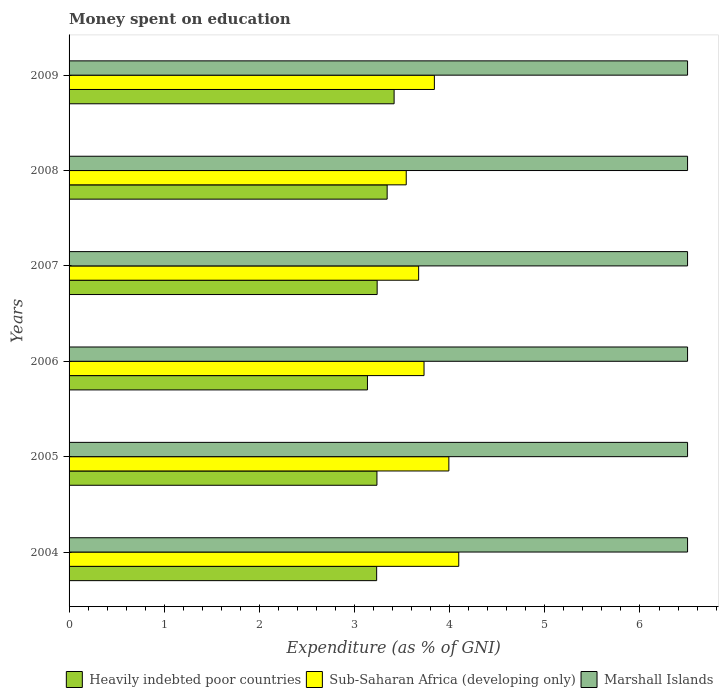How many different coloured bars are there?
Make the answer very short. 3. How many groups of bars are there?
Make the answer very short. 6. How many bars are there on the 3rd tick from the top?
Provide a short and direct response. 3. In how many cases, is the number of bars for a given year not equal to the number of legend labels?
Offer a terse response. 0. What is the amount of money spent on education in Marshall Islands in 2008?
Offer a very short reply. 6.5. Across all years, what is the minimum amount of money spent on education in Marshall Islands?
Your answer should be compact. 6.5. In which year was the amount of money spent on education in Marshall Islands maximum?
Provide a short and direct response. 2004. What is the total amount of money spent on education in Heavily indebted poor countries in the graph?
Ensure brevity in your answer.  19.6. What is the difference between the amount of money spent on education in Heavily indebted poor countries in 2004 and that in 2006?
Ensure brevity in your answer.  0.1. What is the difference between the amount of money spent on education in Marshall Islands in 2004 and the amount of money spent on education in Sub-Saharan Africa (developing only) in 2006?
Provide a succinct answer. 2.77. In the year 2006, what is the difference between the amount of money spent on education in Marshall Islands and amount of money spent on education in Heavily indebted poor countries?
Make the answer very short. 3.36. What is the ratio of the amount of money spent on education in Sub-Saharan Africa (developing only) in 2005 to that in 2007?
Provide a short and direct response. 1.09. What is the difference between the highest and the second highest amount of money spent on education in Sub-Saharan Africa (developing only)?
Provide a short and direct response. 0.1. What is the difference between the highest and the lowest amount of money spent on education in Marshall Islands?
Make the answer very short. 0. In how many years, is the amount of money spent on education in Marshall Islands greater than the average amount of money spent on education in Marshall Islands taken over all years?
Offer a terse response. 0. What does the 2nd bar from the top in 2004 represents?
Your answer should be very brief. Sub-Saharan Africa (developing only). What does the 2nd bar from the bottom in 2008 represents?
Your answer should be compact. Sub-Saharan Africa (developing only). Is it the case that in every year, the sum of the amount of money spent on education in Marshall Islands and amount of money spent on education in Heavily indebted poor countries is greater than the amount of money spent on education in Sub-Saharan Africa (developing only)?
Provide a short and direct response. Yes. How many years are there in the graph?
Ensure brevity in your answer.  6. What is the difference between two consecutive major ticks on the X-axis?
Give a very brief answer. 1. How are the legend labels stacked?
Keep it short and to the point. Horizontal. What is the title of the graph?
Your response must be concise. Money spent on education. Does "Trinidad and Tobago" appear as one of the legend labels in the graph?
Provide a short and direct response. No. What is the label or title of the X-axis?
Give a very brief answer. Expenditure (as % of GNI). What is the label or title of the Y-axis?
Offer a very short reply. Years. What is the Expenditure (as % of GNI) in Heavily indebted poor countries in 2004?
Keep it short and to the point. 3.23. What is the Expenditure (as % of GNI) of Sub-Saharan Africa (developing only) in 2004?
Your response must be concise. 4.1. What is the Expenditure (as % of GNI) in Marshall Islands in 2004?
Your answer should be very brief. 6.5. What is the Expenditure (as % of GNI) of Heavily indebted poor countries in 2005?
Ensure brevity in your answer.  3.24. What is the Expenditure (as % of GNI) of Sub-Saharan Africa (developing only) in 2005?
Ensure brevity in your answer.  3.99. What is the Expenditure (as % of GNI) in Marshall Islands in 2005?
Offer a terse response. 6.5. What is the Expenditure (as % of GNI) in Heavily indebted poor countries in 2006?
Keep it short and to the point. 3.14. What is the Expenditure (as % of GNI) in Sub-Saharan Africa (developing only) in 2006?
Your response must be concise. 3.73. What is the Expenditure (as % of GNI) in Heavily indebted poor countries in 2007?
Offer a very short reply. 3.24. What is the Expenditure (as % of GNI) in Sub-Saharan Africa (developing only) in 2007?
Make the answer very short. 3.67. What is the Expenditure (as % of GNI) of Heavily indebted poor countries in 2008?
Offer a terse response. 3.34. What is the Expenditure (as % of GNI) of Sub-Saharan Africa (developing only) in 2008?
Your answer should be very brief. 3.54. What is the Expenditure (as % of GNI) of Heavily indebted poor countries in 2009?
Your response must be concise. 3.42. What is the Expenditure (as % of GNI) in Sub-Saharan Africa (developing only) in 2009?
Your answer should be very brief. 3.84. What is the Expenditure (as % of GNI) in Marshall Islands in 2009?
Provide a short and direct response. 6.5. Across all years, what is the maximum Expenditure (as % of GNI) in Heavily indebted poor countries?
Your answer should be compact. 3.42. Across all years, what is the maximum Expenditure (as % of GNI) of Sub-Saharan Africa (developing only)?
Provide a succinct answer. 4.1. Across all years, what is the minimum Expenditure (as % of GNI) in Heavily indebted poor countries?
Make the answer very short. 3.14. Across all years, what is the minimum Expenditure (as % of GNI) of Sub-Saharan Africa (developing only)?
Your response must be concise. 3.54. What is the total Expenditure (as % of GNI) of Heavily indebted poor countries in the graph?
Give a very brief answer. 19.6. What is the total Expenditure (as % of GNI) of Sub-Saharan Africa (developing only) in the graph?
Offer a very short reply. 22.87. What is the difference between the Expenditure (as % of GNI) of Heavily indebted poor countries in 2004 and that in 2005?
Offer a terse response. -0. What is the difference between the Expenditure (as % of GNI) in Sub-Saharan Africa (developing only) in 2004 and that in 2005?
Make the answer very short. 0.1. What is the difference between the Expenditure (as % of GNI) of Marshall Islands in 2004 and that in 2005?
Your response must be concise. 0. What is the difference between the Expenditure (as % of GNI) in Heavily indebted poor countries in 2004 and that in 2006?
Your response must be concise. 0.1. What is the difference between the Expenditure (as % of GNI) in Sub-Saharan Africa (developing only) in 2004 and that in 2006?
Give a very brief answer. 0.36. What is the difference between the Expenditure (as % of GNI) in Marshall Islands in 2004 and that in 2006?
Your answer should be compact. 0. What is the difference between the Expenditure (as % of GNI) in Heavily indebted poor countries in 2004 and that in 2007?
Provide a short and direct response. -0.01. What is the difference between the Expenditure (as % of GNI) of Sub-Saharan Africa (developing only) in 2004 and that in 2007?
Provide a succinct answer. 0.42. What is the difference between the Expenditure (as % of GNI) in Marshall Islands in 2004 and that in 2007?
Ensure brevity in your answer.  0. What is the difference between the Expenditure (as % of GNI) in Heavily indebted poor countries in 2004 and that in 2008?
Keep it short and to the point. -0.11. What is the difference between the Expenditure (as % of GNI) in Sub-Saharan Africa (developing only) in 2004 and that in 2008?
Provide a short and direct response. 0.55. What is the difference between the Expenditure (as % of GNI) of Marshall Islands in 2004 and that in 2008?
Ensure brevity in your answer.  0. What is the difference between the Expenditure (as % of GNI) in Heavily indebted poor countries in 2004 and that in 2009?
Provide a succinct answer. -0.18. What is the difference between the Expenditure (as % of GNI) of Sub-Saharan Africa (developing only) in 2004 and that in 2009?
Keep it short and to the point. 0.26. What is the difference between the Expenditure (as % of GNI) in Marshall Islands in 2004 and that in 2009?
Offer a terse response. 0. What is the difference between the Expenditure (as % of GNI) in Heavily indebted poor countries in 2005 and that in 2006?
Your answer should be very brief. 0.1. What is the difference between the Expenditure (as % of GNI) of Sub-Saharan Africa (developing only) in 2005 and that in 2006?
Ensure brevity in your answer.  0.26. What is the difference between the Expenditure (as % of GNI) in Heavily indebted poor countries in 2005 and that in 2007?
Provide a short and direct response. -0. What is the difference between the Expenditure (as % of GNI) in Sub-Saharan Africa (developing only) in 2005 and that in 2007?
Provide a short and direct response. 0.32. What is the difference between the Expenditure (as % of GNI) of Marshall Islands in 2005 and that in 2007?
Offer a terse response. 0. What is the difference between the Expenditure (as % of GNI) of Heavily indebted poor countries in 2005 and that in 2008?
Keep it short and to the point. -0.11. What is the difference between the Expenditure (as % of GNI) of Sub-Saharan Africa (developing only) in 2005 and that in 2008?
Ensure brevity in your answer.  0.45. What is the difference between the Expenditure (as % of GNI) in Heavily indebted poor countries in 2005 and that in 2009?
Offer a terse response. -0.18. What is the difference between the Expenditure (as % of GNI) of Sub-Saharan Africa (developing only) in 2005 and that in 2009?
Your response must be concise. 0.15. What is the difference between the Expenditure (as % of GNI) of Heavily indebted poor countries in 2006 and that in 2007?
Ensure brevity in your answer.  -0.1. What is the difference between the Expenditure (as % of GNI) of Sub-Saharan Africa (developing only) in 2006 and that in 2007?
Your answer should be compact. 0.06. What is the difference between the Expenditure (as % of GNI) of Heavily indebted poor countries in 2006 and that in 2008?
Ensure brevity in your answer.  -0.21. What is the difference between the Expenditure (as % of GNI) in Sub-Saharan Africa (developing only) in 2006 and that in 2008?
Your response must be concise. 0.19. What is the difference between the Expenditure (as % of GNI) in Heavily indebted poor countries in 2006 and that in 2009?
Your answer should be compact. -0.28. What is the difference between the Expenditure (as % of GNI) of Sub-Saharan Africa (developing only) in 2006 and that in 2009?
Your response must be concise. -0.11. What is the difference between the Expenditure (as % of GNI) of Heavily indebted poor countries in 2007 and that in 2008?
Offer a very short reply. -0.11. What is the difference between the Expenditure (as % of GNI) of Sub-Saharan Africa (developing only) in 2007 and that in 2008?
Provide a short and direct response. 0.13. What is the difference between the Expenditure (as % of GNI) of Heavily indebted poor countries in 2007 and that in 2009?
Make the answer very short. -0.18. What is the difference between the Expenditure (as % of GNI) of Sub-Saharan Africa (developing only) in 2007 and that in 2009?
Your response must be concise. -0.17. What is the difference between the Expenditure (as % of GNI) in Marshall Islands in 2007 and that in 2009?
Ensure brevity in your answer.  0. What is the difference between the Expenditure (as % of GNI) in Heavily indebted poor countries in 2008 and that in 2009?
Make the answer very short. -0.07. What is the difference between the Expenditure (as % of GNI) in Sub-Saharan Africa (developing only) in 2008 and that in 2009?
Provide a succinct answer. -0.3. What is the difference between the Expenditure (as % of GNI) in Heavily indebted poor countries in 2004 and the Expenditure (as % of GNI) in Sub-Saharan Africa (developing only) in 2005?
Give a very brief answer. -0.76. What is the difference between the Expenditure (as % of GNI) in Heavily indebted poor countries in 2004 and the Expenditure (as % of GNI) in Marshall Islands in 2005?
Provide a short and direct response. -3.27. What is the difference between the Expenditure (as % of GNI) of Sub-Saharan Africa (developing only) in 2004 and the Expenditure (as % of GNI) of Marshall Islands in 2005?
Give a very brief answer. -2.4. What is the difference between the Expenditure (as % of GNI) in Heavily indebted poor countries in 2004 and the Expenditure (as % of GNI) in Sub-Saharan Africa (developing only) in 2006?
Your response must be concise. -0.5. What is the difference between the Expenditure (as % of GNI) in Heavily indebted poor countries in 2004 and the Expenditure (as % of GNI) in Marshall Islands in 2006?
Your answer should be very brief. -3.27. What is the difference between the Expenditure (as % of GNI) of Sub-Saharan Africa (developing only) in 2004 and the Expenditure (as % of GNI) of Marshall Islands in 2006?
Offer a terse response. -2.4. What is the difference between the Expenditure (as % of GNI) in Heavily indebted poor countries in 2004 and the Expenditure (as % of GNI) in Sub-Saharan Africa (developing only) in 2007?
Your response must be concise. -0.44. What is the difference between the Expenditure (as % of GNI) of Heavily indebted poor countries in 2004 and the Expenditure (as % of GNI) of Marshall Islands in 2007?
Keep it short and to the point. -3.27. What is the difference between the Expenditure (as % of GNI) in Sub-Saharan Africa (developing only) in 2004 and the Expenditure (as % of GNI) in Marshall Islands in 2007?
Provide a succinct answer. -2.4. What is the difference between the Expenditure (as % of GNI) in Heavily indebted poor countries in 2004 and the Expenditure (as % of GNI) in Sub-Saharan Africa (developing only) in 2008?
Offer a terse response. -0.31. What is the difference between the Expenditure (as % of GNI) of Heavily indebted poor countries in 2004 and the Expenditure (as % of GNI) of Marshall Islands in 2008?
Provide a short and direct response. -3.27. What is the difference between the Expenditure (as % of GNI) of Sub-Saharan Africa (developing only) in 2004 and the Expenditure (as % of GNI) of Marshall Islands in 2008?
Offer a very short reply. -2.4. What is the difference between the Expenditure (as % of GNI) in Heavily indebted poor countries in 2004 and the Expenditure (as % of GNI) in Sub-Saharan Africa (developing only) in 2009?
Make the answer very short. -0.61. What is the difference between the Expenditure (as % of GNI) in Heavily indebted poor countries in 2004 and the Expenditure (as % of GNI) in Marshall Islands in 2009?
Give a very brief answer. -3.27. What is the difference between the Expenditure (as % of GNI) in Sub-Saharan Africa (developing only) in 2004 and the Expenditure (as % of GNI) in Marshall Islands in 2009?
Your answer should be compact. -2.4. What is the difference between the Expenditure (as % of GNI) in Heavily indebted poor countries in 2005 and the Expenditure (as % of GNI) in Sub-Saharan Africa (developing only) in 2006?
Give a very brief answer. -0.49. What is the difference between the Expenditure (as % of GNI) of Heavily indebted poor countries in 2005 and the Expenditure (as % of GNI) of Marshall Islands in 2006?
Provide a short and direct response. -3.26. What is the difference between the Expenditure (as % of GNI) of Sub-Saharan Africa (developing only) in 2005 and the Expenditure (as % of GNI) of Marshall Islands in 2006?
Provide a short and direct response. -2.51. What is the difference between the Expenditure (as % of GNI) of Heavily indebted poor countries in 2005 and the Expenditure (as % of GNI) of Sub-Saharan Africa (developing only) in 2007?
Make the answer very short. -0.44. What is the difference between the Expenditure (as % of GNI) in Heavily indebted poor countries in 2005 and the Expenditure (as % of GNI) in Marshall Islands in 2007?
Make the answer very short. -3.26. What is the difference between the Expenditure (as % of GNI) of Sub-Saharan Africa (developing only) in 2005 and the Expenditure (as % of GNI) of Marshall Islands in 2007?
Offer a very short reply. -2.51. What is the difference between the Expenditure (as % of GNI) in Heavily indebted poor countries in 2005 and the Expenditure (as % of GNI) in Sub-Saharan Africa (developing only) in 2008?
Offer a very short reply. -0.31. What is the difference between the Expenditure (as % of GNI) of Heavily indebted poor countries in 2005 and the Expenditure (as % of GNI) of Marshall Islands in 2008?
Your answer should be compact. -3.26. What is the difference between the Expenditure (as % of GNI) of Sub-Saharan Africa (developing only) in 2005 and the Expenditure (as % of GNI) of Marshall Islands in 2008?
Provide a short and direct response. -2.51. What is the difference between the Expenditure (as % of GNI) of Heavily indebted poor countries in 2005 and the Expenditure (as % of GNI) of Sub-Saharan Africa (developing only) in 2009?
Keep it short and to the point. -0.6. What is the difference between the Expenditure (as % of GNI) of Heavily indebted poor countries in 2005 and the Expenditure (as % of GNI) of Marshall Islands in 2009?
Provide a short and direct response. -3.26. What is the difference between the Expenditure (as % of GNI) of Sub-Saharan Africa (developing only) in 2005 and the Expenditure (as % of GNI) of Marshall Islands in 2009?
Give a very brief answer. -2.51. What is the difference between the Expenditure (as % of GNI) in Heavily indebted poor countries in 2006 and the Expenditure (as % of GNI) in Sub-Saharan Africa (developing only) in 2007?
Make the answer very short. -0.54. What is the difference between the Expenditure (as % of GNI) of Heavily indebted poor countries in 2006 and the Expenditure (as % of GNI) of Marshall Islands in 2007?
Provide a succinct answer. -3.36. What is the difference between the Expenditure (as % of GNI) in Sub-Saharan Africa (developing only) in 2006 and the Expenditure (as % of GNI) in Marshall Islands in 2007?
Your answer should be compact. -2.77. What is the difference between the Expenditure (as % of GNI) in Heavily indebted poor countries in 2006 and the Expenditure (as % of GNI) in Sub-Saharan Africa (developing only) in 2008?
Your answer should be very brief. -0.41. What is the difference between the Expenditure (as % of GNI) in Heavily indebted poor countries in 2006 and the Expenditure (as % of GNI) in Marshall Islands in 2008?
Offer a terse response. -3.36. What is the difference between the Expenditure (as % of GNI) in Sub-Saharan Africa (developing only) in 2006 and the Expenditure (as % of GNI) in Marshall Islands in 2008?
Provide a short and direct response. -2.77. What is the difference between the Expenditure (as % of GNI) of Heavily indebted poor countries in 2006 and the Expenditure (as % of GNI) of Sub-Saharan Africa (developing only) in 2009?
Your answer should be compact. -0.7. What is the difference between the Expenditure (as % of GNI) of Heavily indebted poor countries in 2006 and the Expenditure (as % of GNI) of Marshall Islands in 2009?
Offer a very short reply. -3.36. What is the difference between the Expenditure (as % of GNI) of Sub-Saharan Africa (developing only) in 2006 and the Expenditure (as % of GNI) of Marshall Islands in 2009?
Your response must be concise. -2.77. What is the difference between the Expenditure (as % of GNI) of Heavily indebted poor countries in 2007 and the Expenditure (as % of GNI) of Sub-Saharan Africa (developing only) in 2008?
Ensure brevity in your answer.  -0.31. What is the difference between the Expenditure (as % of GNI) in Heavily indebted poor countries in 2007 and the Expenditure (as % of GNI) in Marshall Islands in 2008?
Your response must be concise. -3.26. What is the difference between the Expenditure (as % of GNI) in Sub-Saharan Africa (developing only) in 2007 and the Expenditure (as % of GNI) in Marshall Islands in 2008?
Provide a succinct answer. -2.83. What is the difference between the Expenditure (as % of GNI) of Heavily indebted poor countries in 2007 and the Expenditure (as % of GNI) of Sub-Saharan Africa (developing only) in 2009?
Offer a terse response. -0.6. What is the difference between the Expenditure (as % of GNI) in Heavily indebted poor countries in 2007 and the Expenditure (as % of GNI) in Marshall Islands in 2009?
Your answer should be compact. -3.26. What is the difference between the Expenditure (as % of GNI) in Sub-Saharan Africa (developing only) in 2007 and the Expenditure (as % of GNI) in Marshall Islands in 2009?
Offer a terse response. -2.83. What is the difference between the Expenditure (as % of GNI) in Heavily indebted poor countries in 2008 and the Expenditure (as % of GNI) in Sub-Saharan Africa (developing only) in 2009?
Offer a terse response. -0.5. What is the difference between the Expenditure (as % of GNI) of Heavily indebted poor countries in 2008 and the Expenditure (as % of GNI) of Marshall Islands in 2009?
Your response must be concise. -3.16. What is the difference between the Expenditure (as % of GNI) of Sub-Saharan Africa (developing only) in 2008 and the Expenditure (as % of GNI) of Marshall Islands in 2009?
Give a very brief answer. -2.96. What is the average Expenditure (as % of GNI) of Heavily indebted poor countries per year?
Keep it short and to the point. 3.27. What is the average Expenditure (as % of GNI) in Sub-Saharan Africa (developing only) per year?
Your response must be concise. 3.81. What is the average Expenditure (as % of GNI) of Marshall Islands per year?
Your answer should be very brief. 6.5. In the year 2004, what is the difference between the Expenditure (as % of GNI) of Heavily indebted poor countries and Expenditure (as % of GNI) of Sub-Saharan Africa (developing only)?
Your answer should be very brief. -0.86. In the year 2004, what is the difference between the Expenditure (as % of GNI) in Heavily indebted poor countries and Expenditure (as % of GNI) in Marshall Islands?
Provide a short and direct response. -3.27. In the year 2004, what is the difference between the Expenditure (as % of GNI) in Sub-Saharan Africa (developing only) and Expenditure (as % of GNI) in Marshall Islands?
Keep it short and to the point. -2.4. In the year 2005, what is the difference between the Expenditure (as % of GNI) of Heavily indebted poor countries and Expenditure (as % of GNI) of Sub-Saharan Africa (developing only)?
Your answer should be very brief. -0.76. In the year 2005, what is the difference between the Expenditure (as % of GNI) of Heavily indebted poor countries and Expenditure (as % of GNI) of Marshall Islands?
Offer a terse response. -3.26. In the year 2005, what is the difference between the Expenditure (as % of GNI) of Sub-Saharan Africa (developing only) and Expenditure (as % of GNI) of Marshall Islands?
Ensure brevity in your answer.  -2.51. In the year 2006, what is the difference between the Expenditure (as % of GNI) in Heavily indebted poor countries and Expenditure (as % of GNI) in Sub-Saharan Africa (developing only)?
Provide a succinct answer. -0.59. In the year 2006, what is the difference between the Expenditure (as % of GNI) in Heavily indebted poor countries and Expenditure (as % of GNI) in Marshall Islands?
Keep it short and to the point. -3.36. In the year 2006, what is the difference between the Expenditure (as % of GNI) of Sub-Saharan Africa (developing only) and Expenditure (as % of GNI) of Marshall Islands?
Provide a short and direct response. -2.77. In the year 2007, what is the difference between the Expenditure (as % of GNI) in Heavily indebted poor countries and Expenditure (as % of GNI) in Sub-Saharan Africa (developing only)?
Your answer should be very brief. -0.44. In the year 2007, what is the difference between the Expenditure (as % of GNI) of Heavily indebted poor countries and Expenditure (as % of GNI) of Marshall Islands?
Ensure brevity in your answer.  -3.26. In the year 2007, what is the difference between the Expenditure (as % of GNI) in Sub-Saharan Africa (developing only) and Expenditure (as % of GNI) in Marshall Islands?
Provide a short and direct response. -2.83. In the year 2008, what is the difference between the Expenditure (as % of GNI) of Heavily indebted poor countries and Expenditure (as % of GNI) of Sub-Saharan Africa (developing only)?
Make the answer very short. -0.2. In the year 2008, what is the difference between the Expenditure (as % of GNI) of Heavily indebted poor countries and Expenditure (as % of GNI) of Marshall Islands?
Provide a succinct answer. -3.16. In the year 2008, what is the difference between the Expenditure (as % of GNI) of Sub-Saharan Africa (developing only) and Expenditure (as % of GNI) of Marshall Islands?
Ensure brevity in your answer.  -2.96. In the year 2009, what is the difference between the Expenditure (as % of GNI) in Heavily indebted poor countries and Expenditure (as % of GNI) in Sub-Saharan Africa (developing only)?
Provide a short and direct response. -0.42. In the year 2009, what is the difference between the Expenditure (as % of GNI) in Heavily indebted poor countries and Expenditure (as % of GNI) in Marshall Islands?
Provide a short and direct response. -3.08. In the year 2009, what is the difference between the Expenditure (as % of GNI) in Sub-Saharan Africa (developing only) and Expenditure (as % of GNI) in Marshall Islands?
Provide a short and direct response. -2.66. What is the ratio of the Expenditure (as % of GNI) in Sub-Saharan Africa (developing only) in 2004 to that in 2005?
Your answer should be compact. 1.03. What is the ratio of the Expenditure (as % of GNI) of Heavily indebted poor countries in 2004 to that in 2006?
Ensure brevity in your answer.  1.03. What is the ratio of the Expenditure (as % of GNI) in Sub-Saharan Africa (developing only) in 2004 to that in 2006?
Your answer should be very brief. 1.1. What is the ratio of the Expenditure (as % of GNI) in Sub-Saharan Africa (developing only) in 2004 to that in 2007?
Your response must be concise. 1.11. What is the ratio of the Expenditure (as % of GNI) of Marshall Islands in 2004 to that in 2007?
Provide a succinct answer. 1. What is the ratio of the Expenditure (as % of GNI) in Sub-Saharan Africa (developing only) in 2004 to that in 2008?
Offer a very short reply. 1.16. What is the ratio of the Expenditure (as % of GNI) of Marshall Islands in 2004 to that in 2008?
Ensure brevity in your answer.  1. What is the ratio of the Expenditure (as % of GNI) of Heavily indebted poor countries in 2004 to that in 2009?
Provide a short and direct response. 0.95. What is the ratio of the Expenditure (as % of GNI) in Sub-Saharan Africa (developing only) in 2004 to that in 2009?
Your answer should be compact. 1.07. What is the ratio of the Expenditure (as % of GNI) in Heavily indebted poor countries in 2005 to that in 2006?
Your answer should be compact. 1.03. What is the ratio of the Expenditure (as % of GNI) of Sub-Saharan Africa (developing only) in 2005 to that in 2006?
Give a very brief answer. 1.07. What is the ratio of the Expenditure (as % of GNI) of Sub-Saharan Africa (developing only) in 2005 to that in 2007?
Your answer should be compact. 1.09. What is the ratio of the Expenditure (as % of GNI) of Heavily indebted poor countries in 2005 to that in 2008?
Provide a short and direct response. 0.97. What is the ratio of the Expenditure (as % of GNI) of Sub-Saharan Africa (developing only) in 2005 to that in 2008?
Your answer should be very brief. 1.13. What is the ratio of the Expenditure (as % of GNI) in Heavily indebted poor countries in 2005 to that in 2009?
Your answer should be very brief. 0.95. What is the ratio of the Expenditure (as % of GNI) of Sub-Saharan Africa (developing only) in 2005 to that in 2009?
Offer a very short reply. 1.04. What is the ratio of the Expenditure (as % of GNI) in Heavily indebted poor countries in 2006 to that in 2007?
Your response must be concise. 0.97. What is the ratio of the Expenditure (as % of GNI) of Sub-Saharan Africa (developing only) in 2006 to that in 2007?
Your response must be concise. 1.02. What is the ratio of the Expenditure (as % of GNI) of Heavily indebted poor countries in 2006 to that in 2008?
Make the answer very short. 0.94. What is the ratio of the Expenditure (as % of GNI) of Sub-Saharan Africa (developing only) in 2006 to that in 2008?
Keep it short and to the point. 1.05. What is the ratio of the Expenditure (as % of GNI) in Heavily indebted poor countries in 2006 to that in 2009?
Provide a succinct answer. 0.92. What is the ratio of the Expenditure (as % of GNI) of Sub-Saharan Africa (developing only) in 2006 to that in 2009?
Provide a succinct answer. 0.97. What is the ratio of the Expenditure (as % of GNI) of Heavily indebted poor countries in 2007 to that in 2008?
Keep it short and to the point. 0.97. What is the ratio of the Expenditure (as % of GNI) in Sub-Saharan Africa (developing only) in 2007 to that in 2008?
Provide a short and direct response. 1.04. What is the ratio of the Expenditure (as % of GNI) in Marshall Islands in 2007 to that in 2008?
Give a very brief answer. 1. What is the ratio of the Expenditure (as % of GNI) of Heavily indebted poor countries in 2007 to that in 2009?
Provide a short and direct response. 0.95. What is the ratio of the Expenditure (as % of GNI) of Sub-Saharan Africa (developing only) in 2007 to that in 2009?
Offer a terse response. 0.96. What is the ratio of the Expenditure (as % of GNI) of Heavily indebted poor countries in 2008 to that in 2009?
Provide a succinct answer. 0.98. What is the ratio of the Expenditure (as % of GNI) in Sub-Saharan Africa (developing only) in 2008 to that in 2009?
Keep it short and to the point. 0.92. What is the ratio of the Expenditure (as % of GNI) in Marshall Islands in 2008 to that in 2009?
Keep it short and to the point. 1. What is the difference between the highest and the second highest Expenditure (as % of GNI) in Heavily indebted poor countries?
Keep it short and to the point. 0.07. What is the difference between the highest and the second highest Expenditure (as % of GNI) in Sub-Saharan Africa (developing only)?
Keep it short and to the point. 0.1. What is the difference between the highest and the second highest Expenditure (as % of GNI) in Marshall Islands?
Your answer should be very brief. 0. What is the difference between the highest and the lowest Expenditure (as % of GNI) of Heavily indebted poor countries?
Offer a very short reply. 0.28. What is the difference between the highest and the lowest Expenditure (as % of GNI) of Sub-Saharan Africa (developing only)?
Provide a succinct answer. 0.55. What is the difference between the highest and the lowest Expenditure (as % of GNI) in Marshall Islands?
Keep it short and to the point. 0. 